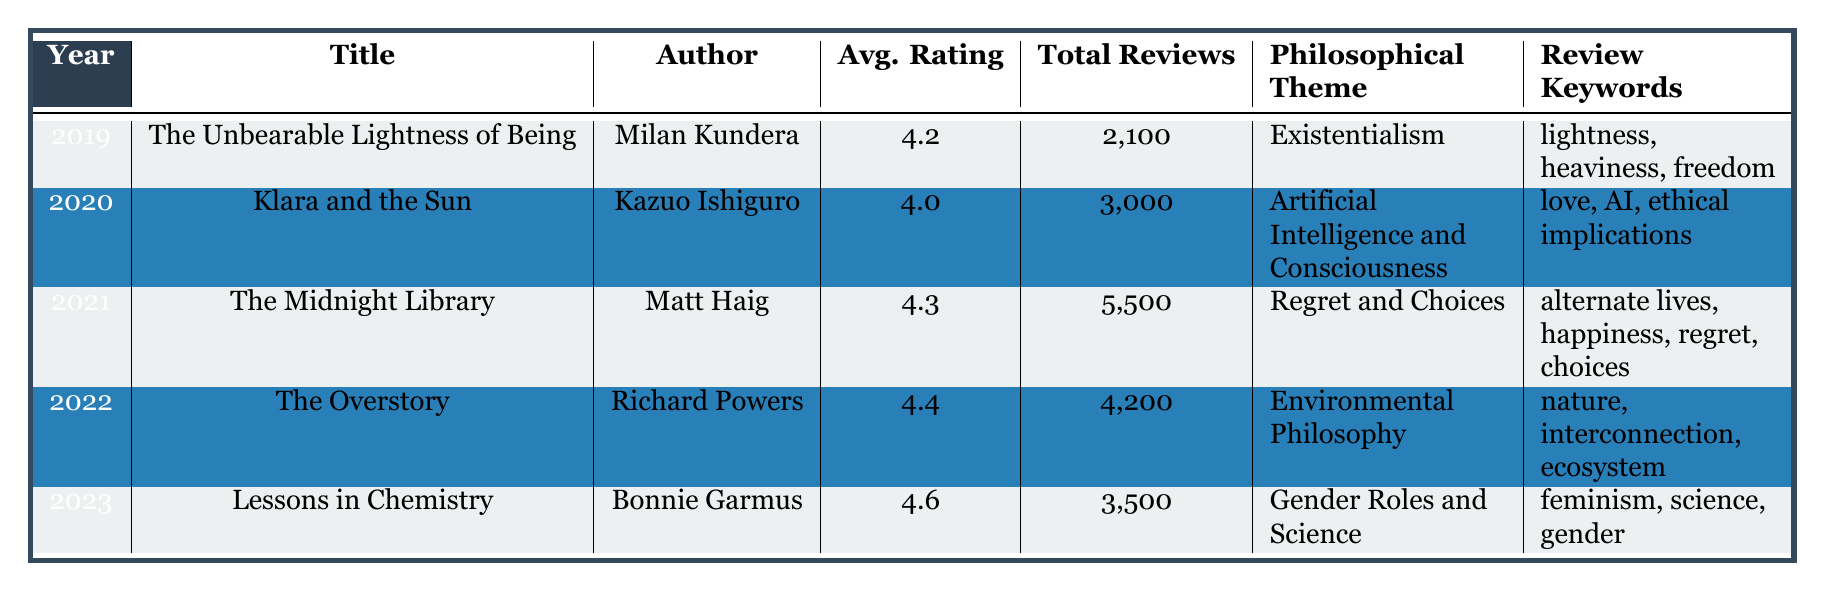What is the book with the highest average rating? The table lists the average ratings for each book. "Lessons in Chemistry" has the highest average rating of 4.6.
Answer: Lessons in Chemistry How many total reviews did "The Midnight Library" receive? According to the table, "The Midnight Library" received a total of 5,500 reviews.
Answer: 5,500 Which author wrote a book in 2022 focused on Environmental Philosophy? The table indicates that Richard Powers wrote "The Overstory," which covers Environmental Philosophy in 2022.
Answer: Richard Powers What is the philosophical theme of "Klara and the Sun"? The table states that "Klara and the Sun" is centered on the philosophical theme of Artificial Intelligence and Consciousness.
Answer: Artificial Intelligence and Consciousness What is the average rating of books released from 2019 to 2023? To find the average, add all the ratings (4.2 + 4.0 + 4.3 + 4.4 + 4.6 = 21.5) and divide by the number of books (5). The average rating is 21.5 / 5 = 4.3.
Answer: 4.3 Is the total number of reviews for "Lessons in Chemistry" greater than that for "The Overstory"? The table shows that "Lessons in Chemistry" has 3,500 reviews and "The Overstory" has 4,200 reviews. Therefore, the number of reviews for "Lessons in Chemistry" is not greater.
Answer: No What years featured books exploring regret or choices, and what were their average ratings? The table shows that "The Midnight Library" explored regret and choices in 2021, with an average rating of 4.3.
Answer: 2021, 4.3 Which philosophical theme was most consistently rated above 4.4 between 2019 and 2023? Reviewing the average ratings, both "The Overstory" (4.4) and "Lessons in Chemistry" (4.6) were above 4.4, but "Lessons in Chemistry" had the highest rating of 4.6 in 2023.
Answer: Gender Roles and Science How many more total reviews did "The Midnight Library" receive compared to "Klara and the Sun"? The review counts are 5,500 for "The Midnight Library" and 3,000 for "Klara and the Sun." The difference is 5,500 - 3,000 = 2,500.
Answer: 2,500 Is "The Overstory" the only book with an average rating over 4.4 from 2019 to 2023? The table shows "The Overstory" with 4.4 and "Lessons in Chemistry" with 4.6, so it is not the only one.
Answer: No 